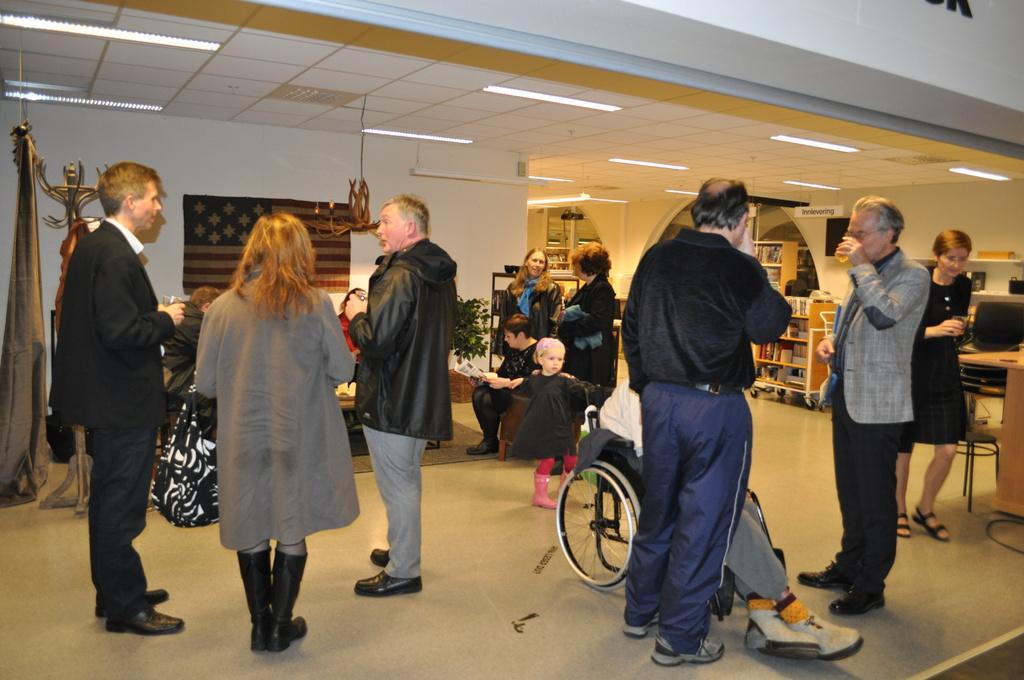Could you give a brief overview of what you see in this image? This is the picture of a place where we have some people standing, among them a person is on the wheel chair and around there are some tables, shelves and some other around. 